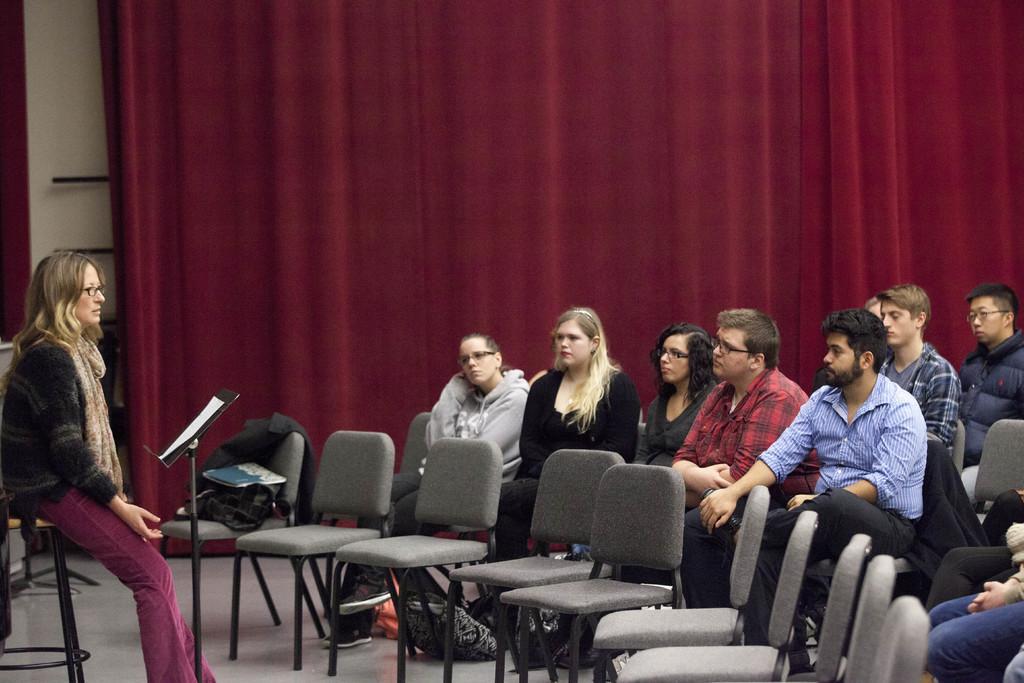Could you give a brief overview of what you see in this image? In this picture I can see group of people sitting on the chairs, there is a paper on the stand, and in the background there are curtains. 